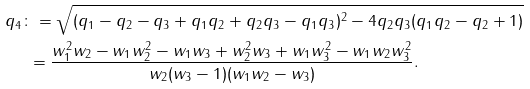<formula> <loc_0><loc_0><loc_500><loc_500>q _ { 4 } & \colon = \sqrt { ( q _ { 1 } - q _ { 2 } - q _ { 3 } + q _ { 1 } q _ { 2 } + q _ { 2 } q _ { 3 } - q _ { 1 } q _ { 3 } ) ^ { 2 } - 4 q _ { 2 } q _ { 3 } ( q _ { 1 } q _ { 2 } - q _ { 2 } + 1 ) } \\ & \ = \frac { w _ { 1 } ^ { 2 } w _ { 2 } - w _ { 1 } w _ { 2 } ^ { 2 } - w _ { 1 } w _ { 3 } + w _ { 2 } ^ { 2 } w _ { 3 } + w _ { 1 } w _ { 3 } ^ { 2 } - w _ { 1 } w _ { 2 } w _ { 3 } ^ { 2 } } { w _ { 2 } ( w _ { 3 } - 1 ) ( w _ { 1 } w _ { 2 } - w _ { 3 } ) } .</formula> 